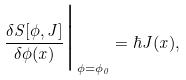<formula> <loc_0><loc_0><loc_500><loc_500>\frac { \delta S [ \phi , J ] } { \delta \phi ( x ) } \Big | _ { \phi = \phi _ { 0 } } = \hbar { J } ( x ) ,</formula> 